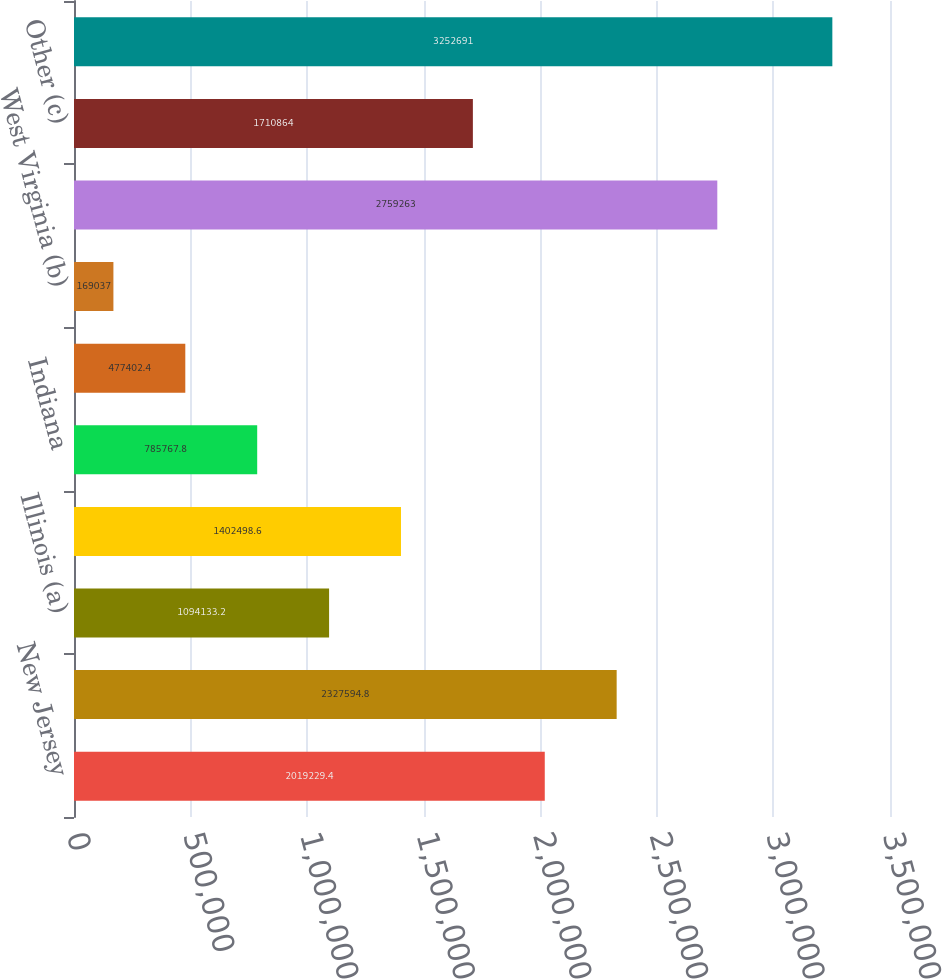<chart> <loc_0><loc_0><loc_500><loc_500><bar_chart><fcel>New Jersey<fcel>Pennsylvania<fcel>Illinois (a)<fcel>Missouri<fcel>Indiana<fcel>California<fcel>West Virginia (b)<fcel>Subtotal (Top Seven States)<fcel>Other (c)<fcel>Total Regulated Businesses<nl><fcel>2.01923e+06<fcel>2.32759e+06<fcel>1.09413e+06<fcel>1.4025e+06<fcel>785768<fcel>477402<fcel>169037<fcel>2.75926e+06<fcel>1.71086e+06<fcel>3.25269e+06<nl></chart> 